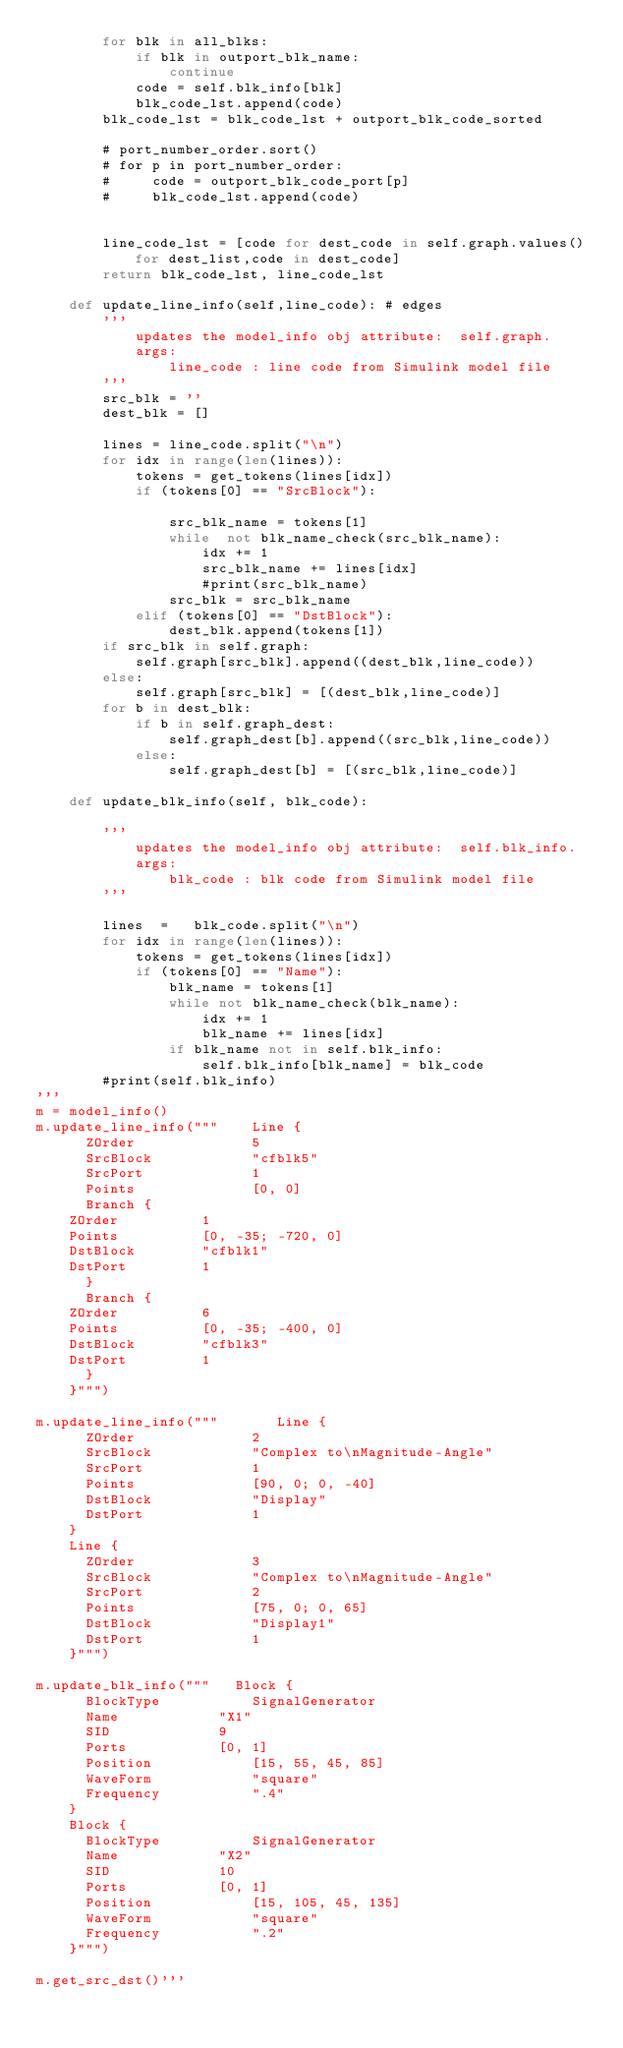Convert code to text. <code><loc_0><loc_0><loc_500><loc_500><_Python_>        for blk in all_blks:
            if blk in outport_blk_name:
                continue
            code = self.blk_info[blk]
            blk_code_lst.append(code)
        blk_code_lst = blk_code_lst + outport_blk_code_sorted

        # port_number_order.sort()
        # for p in port_number_order:
        #     code = outport_blk_code_port[p]
        #     blk_code_lst.append(code)


        line_code_lst = [code for dest_code in self.graph.values() for dest_list,code in dest_code]
        return blk_code_lst, line_code_lst

    def update_line_info(self,line_code): # edges
        '''
            updates the model_info obj attribute:  self.graph.
            args:
                line_code : line code from Simulink model file
        '''
        src_blk = ''
        dest_blk = []

        lines = line_code.split("\n")
        for idx in range(len(lines)):
            tokens = get_tokens(lines[idx])
            if (tokens[0] == "SrcBlock"):

                src_blk_name = tokens[1]
                while  not blk_name_check(src_blk_name):
                    idx += 1
                    src_blk_name += lines[idx]
                    #print(src_blk_name)
                src_blk = src_blk_name
            elif (tokens[0] == "DstBlock"):
                dest_blk.append(tokens[1])
        if src_blk in self.graph:
            self.graph[src_blk].append((dest_blk,line_code))
        else:
            self.graph[src_blk] = [(dest_blk,line_code)]
        for b in dest_blk:
            if b in self.graph_dest:
                self.graph_dest[b].append((src_blk,line_code))
            else:
                self.graph_dest[b] = [(src_blk,line_code)]

    def update_blk_info(self, blk_code):

        '''
            updates the model_info obj attribute:  self.blk_info.
            args:
                blk_code : blk code from Simulink model file
        '''

        lines  =   blk_code.split("\n")
        for idx in range(len(lines)):
            tokens = get_tokens(lines[idx])
            if (tokens[0] == "Name"):
                blk_name = tokens[1]
                while not blk_name_check(blk_name):
                    idx += 1
                    blk_name += lines[idx]
                if blk_name not in self.blk_info:
                    self.blk_info[blk_name] = blk_code
        #print(self.blk_info)
'''
m = model_info()
m.update_line_info("""    Line {
      ZOrder		      5
      SrcBlock		      "cfblk5"
      SrcPort		      1
      Points		      [0, 0]
      Branch {
	ZOrder			1
	Points			[0, -35; -720, 0]
	DstBlock		"cfblk1"
	DstPort			1
      }
      Branch {
	ZOrder			6
	Points			[0, -35; -400, 0]
	DstBlock		"cfblk3"
	DstPort			1
      }
    }""")

m.update_line_info("""       Line {
      ZOrder		      2
      SrcBlock		      "Complex to\nMagnitude-Angle"
      SrcPort		      1
      Points		      [90, 0; 0, -40]
      DstBlock		      "Display"
      DstPort		      1
    }
    Line {
      ZOrder		      3
      SrcBlock		      "Complex to\nMagnitude-Angle"
      SrcPort		      2
      Points		      [75, 0; 0, 65]
      DstBlock		      "Display1"
      DstPort		      1
    }""")

m.update_blk_info("""   Block {
      BlockType		      SignalGenerator
      Name		      "X1"
      SID		      9
      Ports		      [0, 1]
      Position		      [15, 55, 45, 85]
      WaveForm		      "square"
      Frequency		      ".4"
    }
    Block {
      BlockType		      SignalGenerator
      Name		      "X2"
      SID		      10
      Ports		      [0, 1]
      Position		      [15, 105, 45, 135]
      WaveForm		      "square"
      Frequency		      ".2"
    }""")

m.get_src_dst()'''</code> 